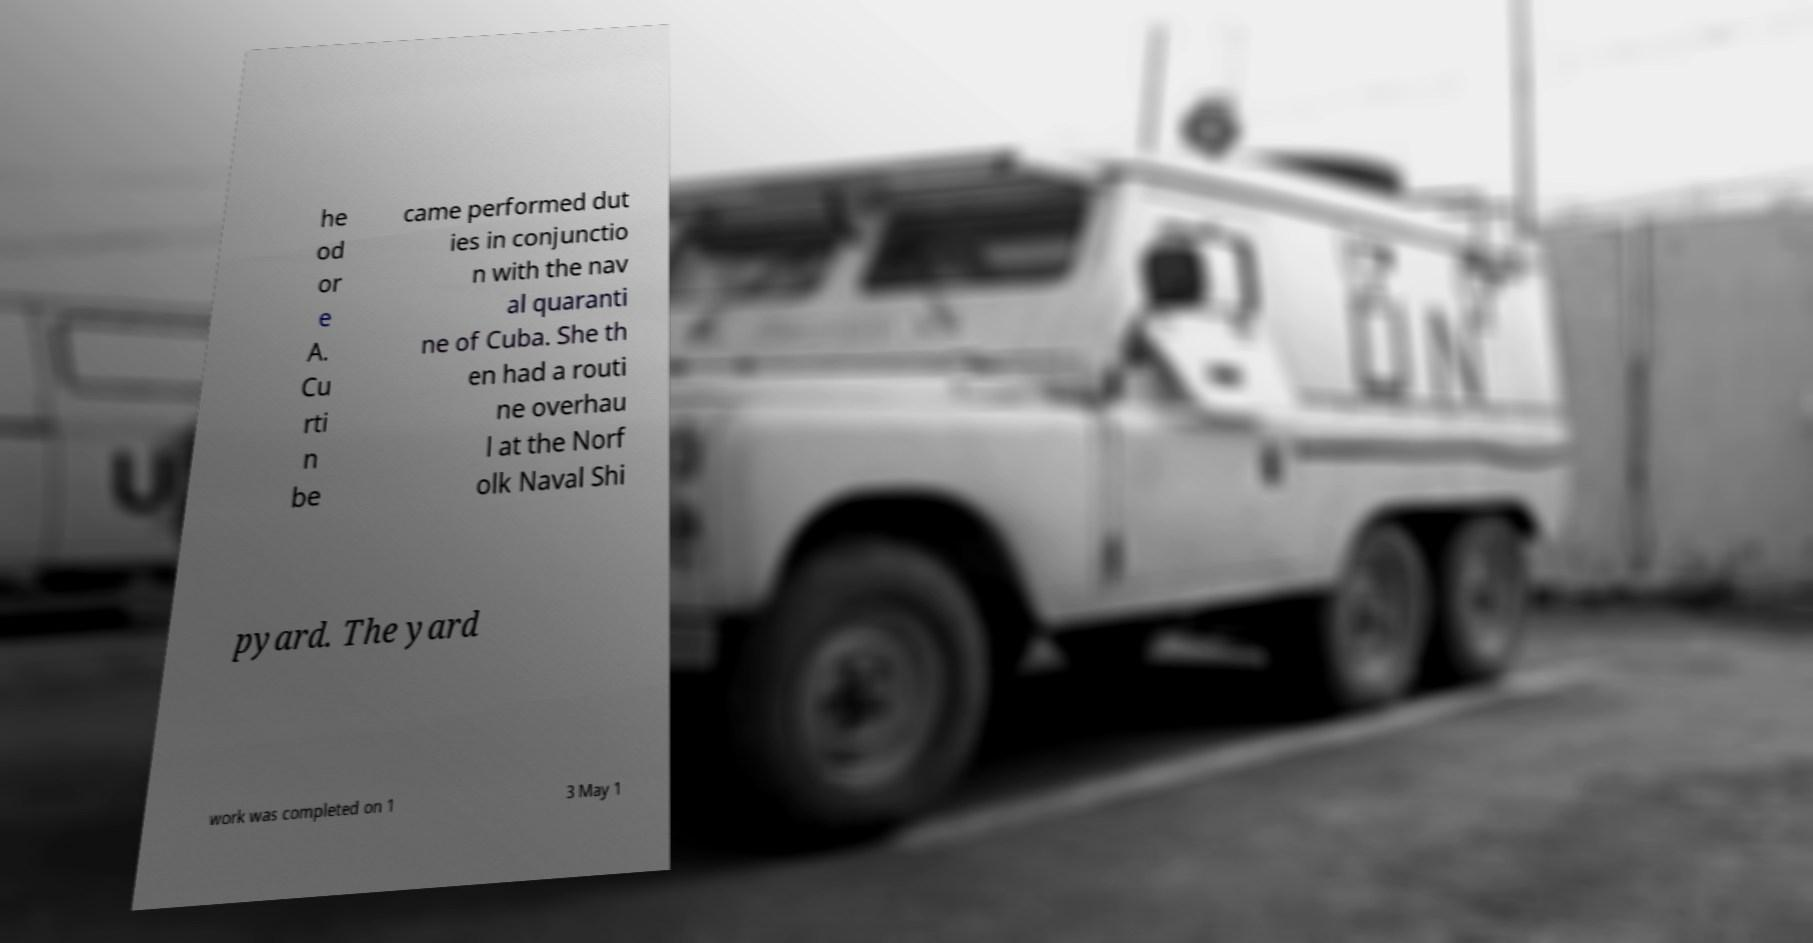Could you extract and type out the text from this image? he od or e A. Cu rti n be came performed dut ies in conjunctio n with the nav al quaranti ne of Cuba. She th en had a routi ne overhau l at the Norf olk Naval Shi pyard. The yard work was completed on 1 3 May 1 